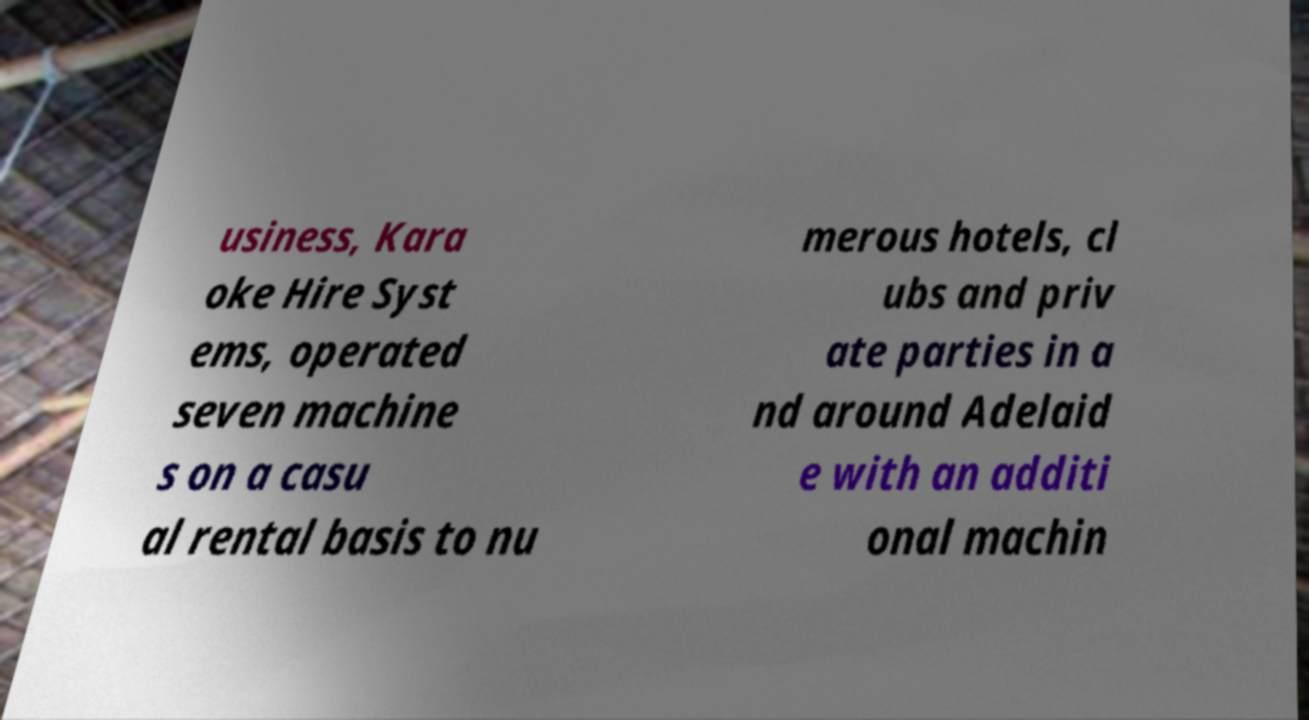Could you extract and type out the text from this image? usiness, Kara oke Hire Syst ems, operated seven machine s on a casu al rental basis to nu merous hotels, cl ubs and priv ate parties in a nd around Adelaid e with an additi onal machin 